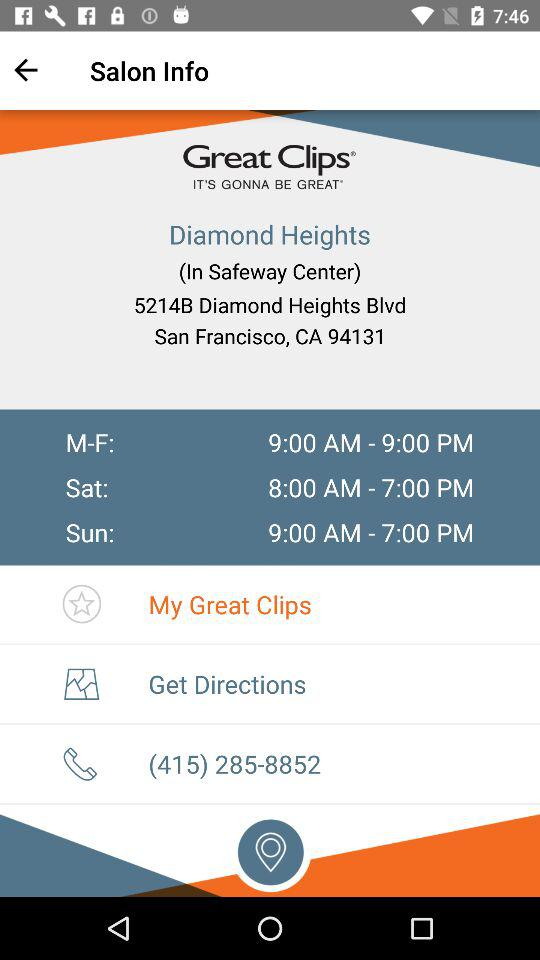What is the timing for Satuday? The timing ranges from 8:00 AM to 7:00 PM. 